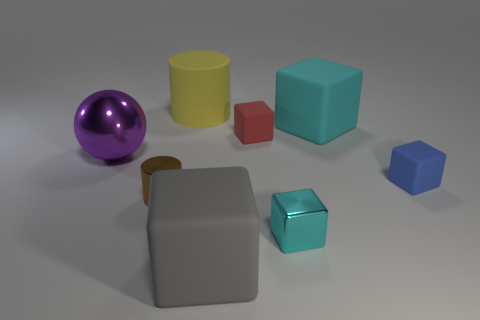Subtract 3 blocks. How many blocks are left? 2 Subtract all red blocks. How many blocks are left? 4 Subtract all blue cubes. How many cubes are left? 4 Add 1 large cyan rubber objects. How many objects exist? 9 Subtract all blue cubes. Subtract all cyan cylinders. How many cubes are left? 4 Subtract all cylinders. How many objects are left? 6 Add 7 large metal objects. How many large metal objects are left? 8 Add 4 large cyan matte objects. How many large cyan matte objects exist? 5 Subtract 1 purple spheres. How many objects are left? 7 Subtract all brown metallic objects. Subtract all big cyan things. How many objects are left? 6 